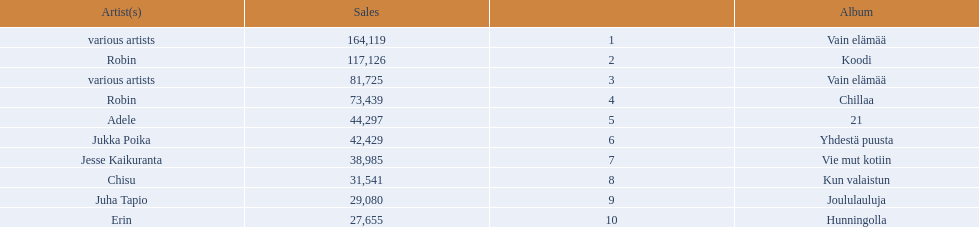Which were the number-one albums of 2012 in finland? Vain elämää, Koodi, Vain elämää, Chillaa, 21, Yhdestä puusta, Vie mut kotiin, Kun valaistun, Joululauluja, Hunningolla. Of those albums, which were by robin? Koodi, Chillaa. Of those albums by robin, which is not chillaa? Koodi. 